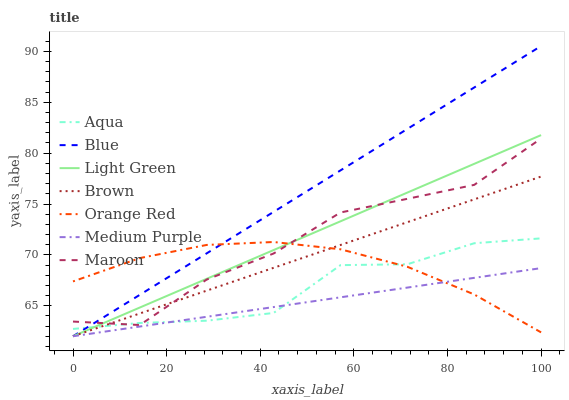Does Brown have the minimum area under the curve?
Answer yes or no. No. Does Brown have the maximum area under the curve?
Answer yes or no. No. Is Aqua the smoothest?
Answer yes or no. No. Is Aqua the roughest?
Answer yes or no. No. Does Aqua have the lowest value?
Answer yes or no. No. Does Brown have the highest value?
Answer yes or no. No. Is Medium Purple less than Maroon?
Answer yes or no. Yes. Is Maroon greater than Medium Purple?
Answer yes or no. Yes. Does Medium Purple intersect Maroon?
Answer yes or no. No. 